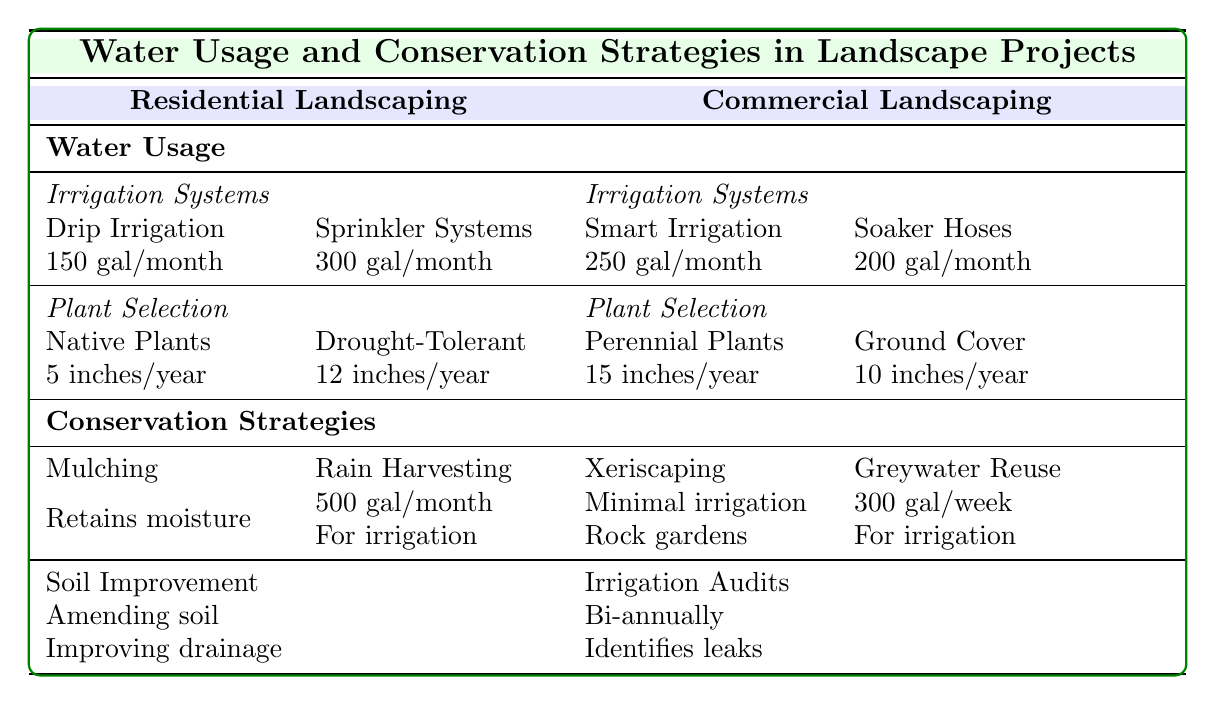what is the average water usage per month for Drip Irrigation? The table states that Drip Irrigation has an average usage of 150 gallons per month. This value can be found directly under the "Water Usage" section for "Irrigation Systems" in Residential Landscaping.
Answer: 150 gallons what are the benefits of using mulching? The table lists two benefits of mulching: it retains soil moisture and reduces weed growth. These benefits are mentioned under the Conservation Strategies section for Residential Landscaping.
Answer: Retains soil moisture, reduces weed growth how much water does the Smart Irrigation system use monthly? According to the table, the Smart Irrigation system has an average usage of 250 gallons per month, this figure is found in the Commercial Landscaping section under "Irrigation Systems."
Answer: 250 gallons what is the total average water requirement for Native and Drought-Tolerant plants? The average water requirement for Native Plants is 5 inches per year and for Drought-Tolerant Plants is 12 inches per year. To find the total, add these two values: 5 + 12 = 17 inches per year as a collective irrigation need.
Answer: 17 inches is Greywater Reuse utilized for irrigation? Yes, the table indicates that Greywater Reuse, which has an estimated volume reused of 300 gallons per week, can be utilized for irrigation. This detail is provided in the Conservation Strategies section for Commercial Landscaping.
Answer: Yes what is the difference in average monthly water usage between the Sprinkler Systems and Soaker Hoses? The average monthly water usage for Sprinkler Systems is 300 gallons and for Soaker Hoses, it is 200 gallons. To calculate the difference: 300 - 200 = 100 gallons. Therefore, the difference in usage is 100 gallons.
Answer: 100 gallons how often are irrigation audits conducted? The table states that irrigation audits are conducted bi-annually. This information is located in the Conservation Strategies section under Commercial Landscaping.
Answer: Bi-annually how does the average water requirement for perennial plants compare to that of ground cover plants? The average water requirement for Perennial Plants is 15 inches per year, while Ground Cover Plants require 10 inches per year. To compare: 15 - 10 = 5 inches more is needed for perennial plants. Thus, perennial plants need 5 inches more water on average than ground cover plants.
Answer: 5 inches what is the average water collection volume for rain harvesting? The table notes that rain harvesting has a collection volume of 500 gallons per month. This is found in the Conservation Strategies for Residential Landscaping.
Answer: 500 gallons 